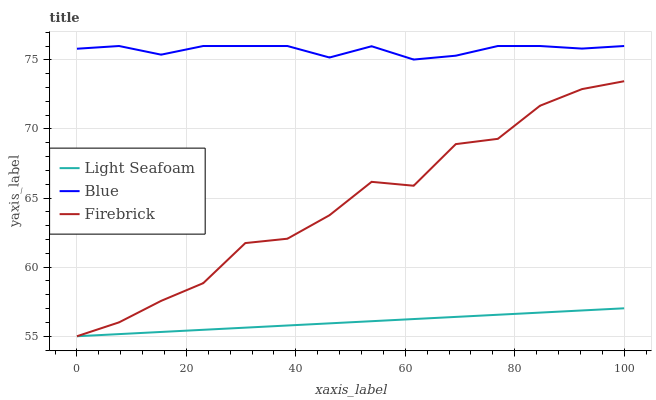Does Light Seafoam have the minimum area under the curve?
Answer yes or no. Yes. Does Blue have the maximum area under the curve?
Answer yes or no. Yes. Does Firebrick have the minimum area under the curve?
Answer yes or no. No. Does Firebrick have the maximum area under the curve?
Answer yes or no. No. Is Light Seafoam the smoothest?
Answer yes or no. Yes. Is Firebrick the roughest?
Answer yes or no. Yes. Is Firebrick the smoothest?
Answer yes or no. No. Is Light Seafoam the roughest?
Answer yes or no. No. Does Firebrick have the lowest value?
Answer yes or no. Yes. Does Blue have the highest value?
Answer yes or no. Yes. Does Firebrick have the highest value?
Answer yes or no. No. Is Firebrick less than Blue?
Answer yes or no. Yes. Is Blue greater than Firebrick?
Answer yes or no. Yes. Does Firebrick intersect Light Seafoam?
Answer yes or no. Yes. Is Firebrick less than Light Seafoam?
Answer yes or no. No. Is Firebrick greater than Light Seafoam?
Answer yes or no. No. Does Firebrick intersect Blue?
Answer yes or no. No. 